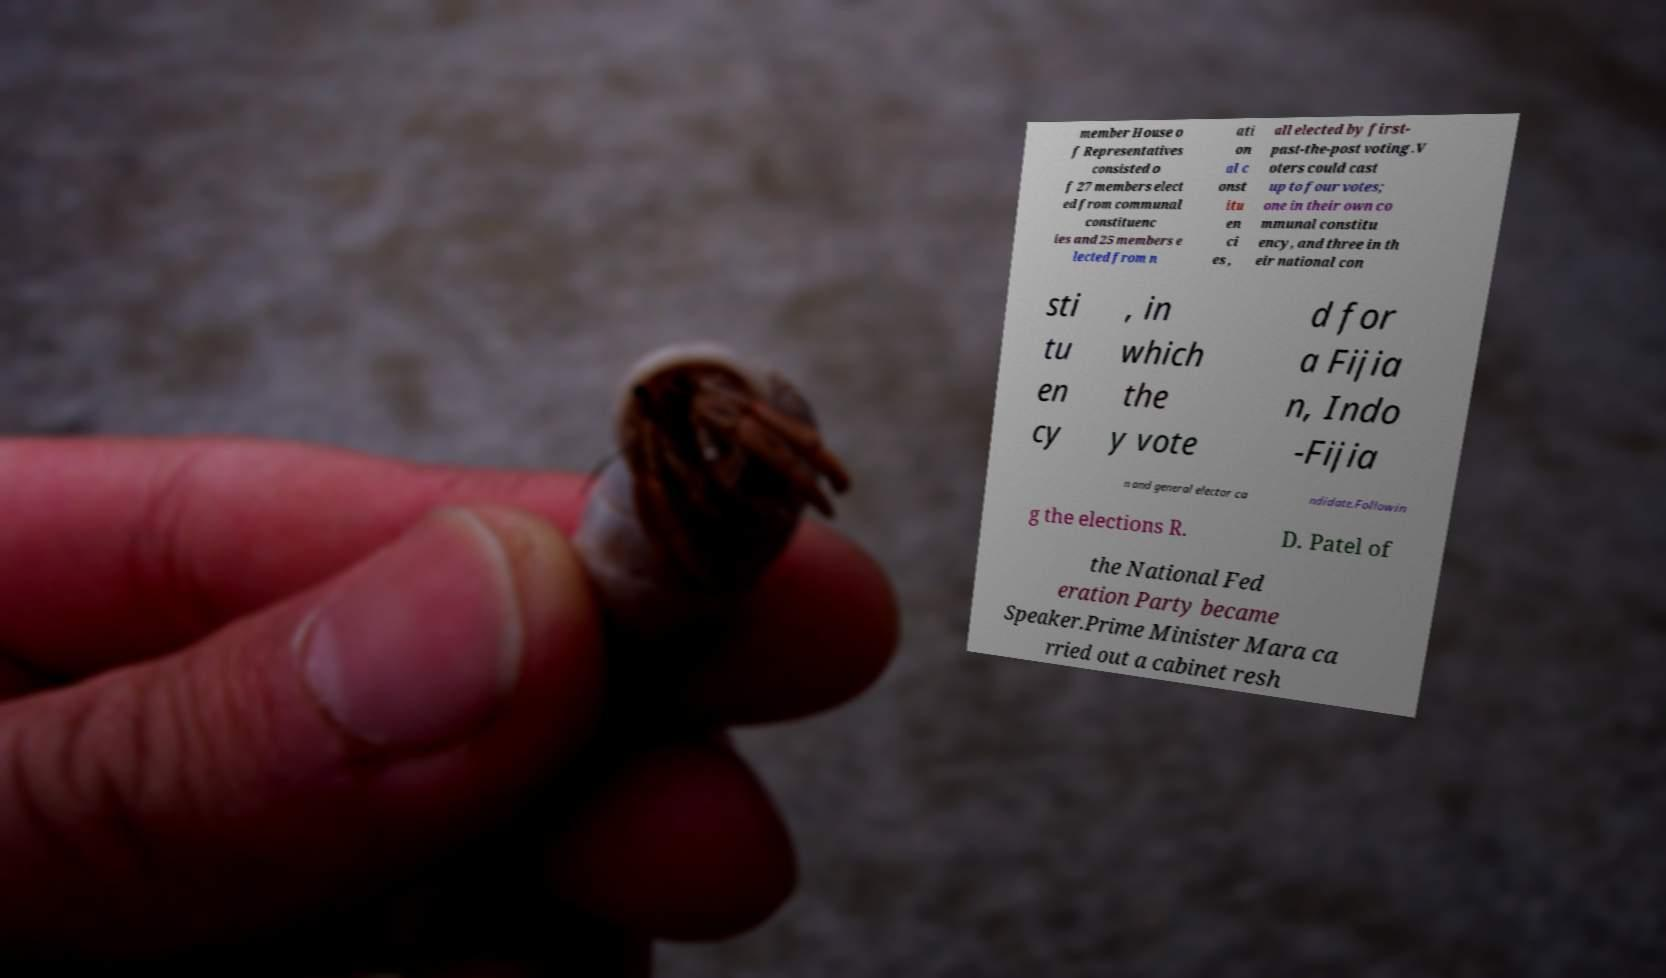Please identify and transcribe the text found in this image. member House o f Representatives consisted o f 27 members elect ed from communal constituenc ies and 25 members e lected from n ati on al c onst itu en ci es , all elected by first- past-the-post voting.V oters could cast up to four votes; one in their own co mmunal constitu ency, and three in th eir national con sti tu en cy , in which the y vote d for a Fijia n, Indo -Fijia n and general elector ca ndidate.Followin g the elections R. D. Patel of the National Fed eration Party became Speaker.Prime Minister Mara ca rried out a cabinet resh 